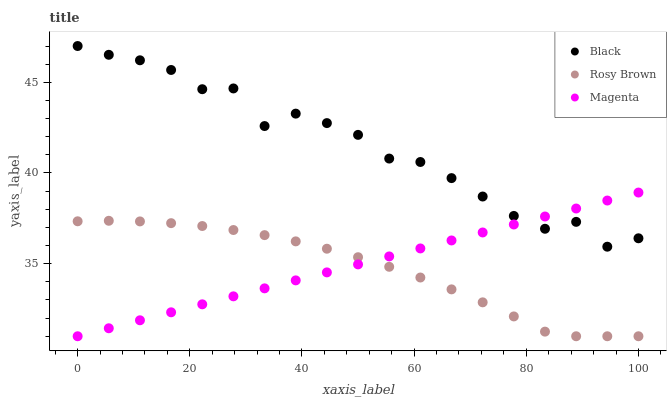Does Rosy Brown have the minimum area under the curve?
Answer yes or no. Yes. Does Black have the maximum area under the curve?
Answer yes or no. Yes. Does Black have the minimum area under the curve?
Answer yes or no. No. Does Rosy Brown have the maximum area under the curve?
Answer yes or no. No. Is Magenta the smoothest?
Answer yes or no. Yes. Is Black the roughest?
Answer yes or no. Yes. Is Rosy Brown the smoothest?
Answer yes or no. No. Is Rosy Brown the roughest?
Answer yes or no. No. Does Magenta have the lowest value?
Answer yes or no. Yes. Does Black have the lowest value?
Answer yes or no. No. Does Black have the highest value?
Answer yes or no. Yes. Does Rosy Brown have the highest value?
Answer yes or no. No. Is Rosy Brown less than Black?
Answer yes or no. Yes. Is Black greater than Rosy Brown?
Answer yes or no. Yes. Does Magenta intersect Rosy Brown?
Answer yes or no. Yes. Is Magenta less than Rosy Brown?
Answer yes or no. No. Is Magenta greater than Rosy Brown?
Answer yes or no. No. Does Rosy Brown intersect Black?
Answer yes or no. No. 